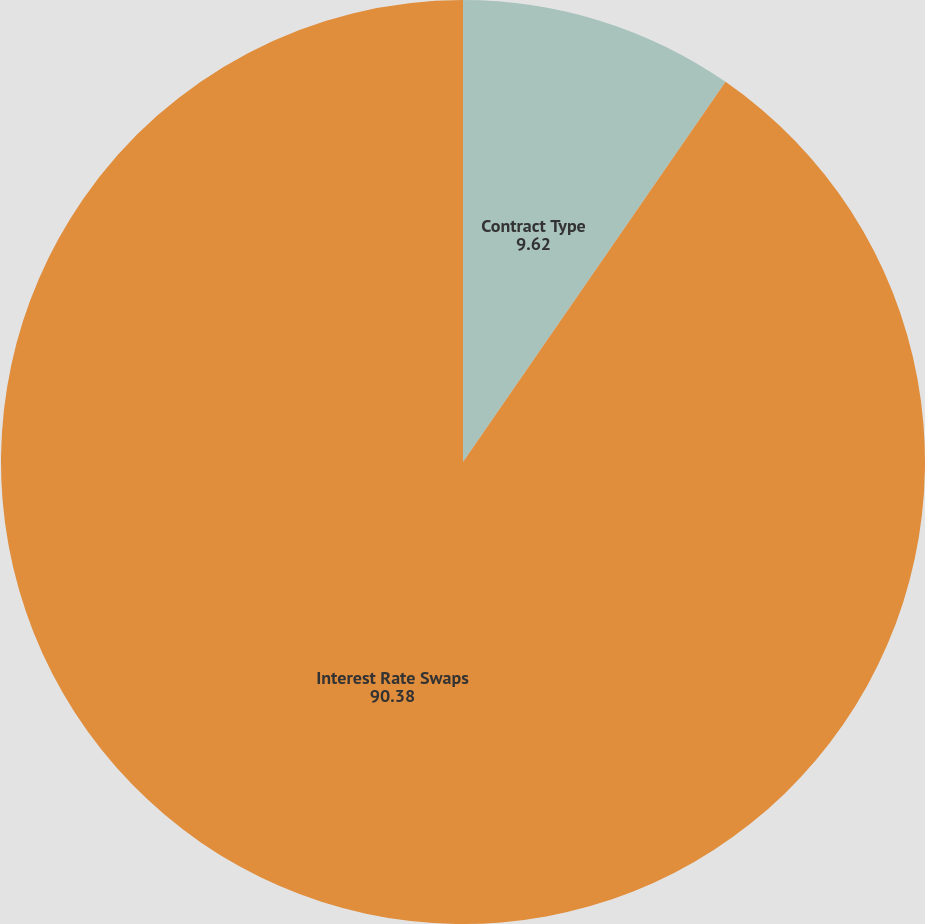Convert chart. <chart><loc_0><loc_0><loc_500><loc_500><pie_chart><fcel>Contract Type<fcel>Interest Rate Swaps<nl><fcel>9.62%<fcel>90.38%<nl></chart> 